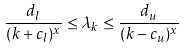<formula> <loc_0><loc_0><loc_500><loc_500>\frac { d _ { l } } { ( k + c _ { l } ) ^ { x } } \leq \lambda _ { k } \leq \frac { d _ { u } } { ( k - c _ { u } ) ^ { x } }</formula> 